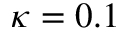<formula> <loc_0><loc_0><loc_500><loc_500>\kappa = 0 . 1</formula> 